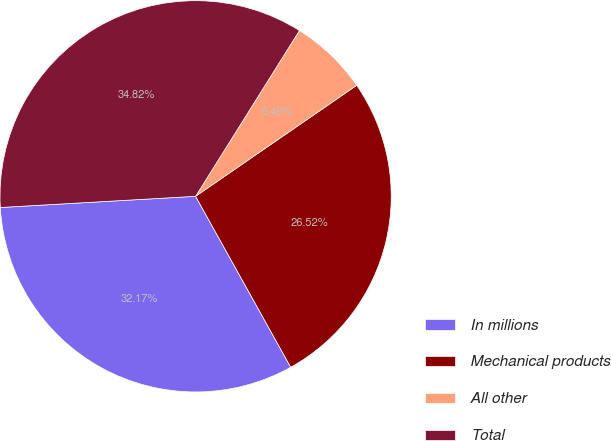Convert chart. <chart><loc_0><loc_0><loc_500><loc_500><pie_chart><fcel>In millions<fcel>Mechanical products<fcel>All other<fcel>Total<nl><fcel>32.17%<fcel>26.52%<fcel>6.49%<fcel>34.82%<nl></chart> 